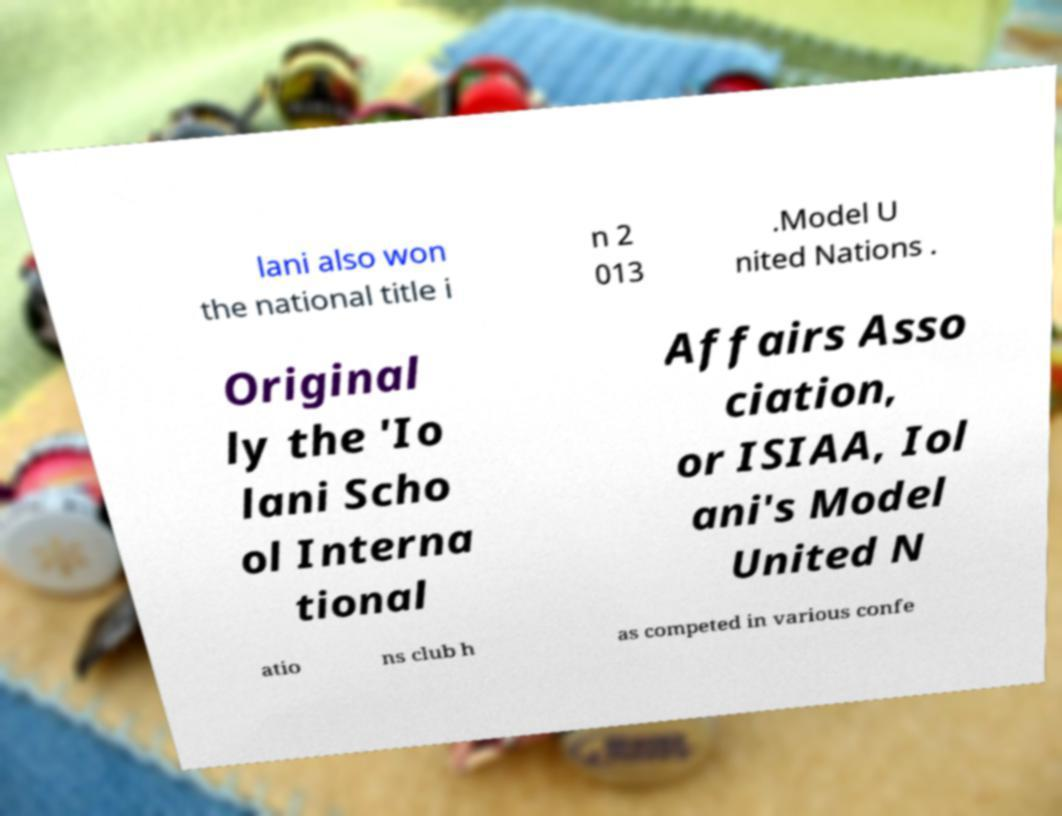Can you accurately transcribe the text from the provided image for me? lani also won the national title i n 2 013 .Model U nited Nations . Original ly the 'Io lani Scho ol Interna tional Affairs Asso ciation, or ISIAA, Iol ani's Model United N atio ns club h as competed in various confe 